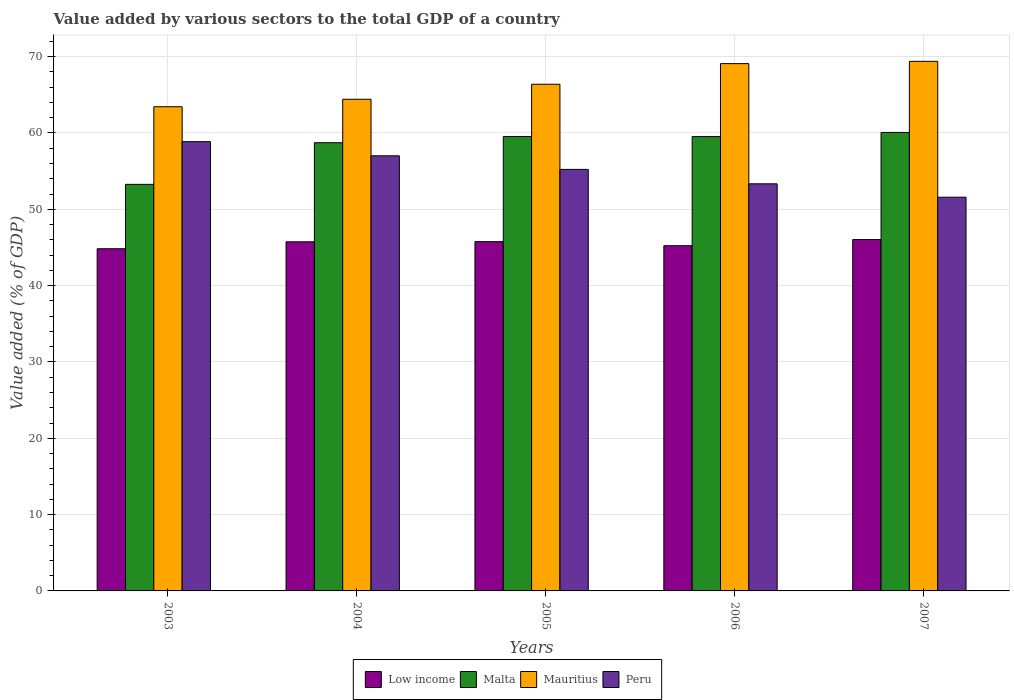How many different coloured bars are there?
Provide a short and direct response. 4. How many groups of bars are there?
Provide a succinct answer. 5. Are the number of bars on each tick of the X-axis equal?
Your response must be concise. Yes. How many bars are there on the 3rd tick from the right?
Keep it short and to the point. 4. What is the label of the 2nd group of bars from the left?
Your answer should be very brief. 2004. In how many cases, is the number of bars for a given year not equal to the number of legend labels?
Your answer should be compact. 0. What is the value added by various sectors to the total GDP in Peru in 2004?
Your answer should be very brief. 57.01. Across all years, what is the maximum value added by various sectors to the total GDP in Mauritius?
Offer a very short reply. 69.38. Across all years, what is the minimum value added by various sectors to the total GDP in Peru?
Keep it short and to the point. 51.58. In which year was the value added by various sectors to the total GDP in Mauritius maximum?
Make the answer very short. 2007. What is the total value added by various sectors to the total GDP in Peru in the graph?
Provide a short and direct response. 276.01. What is the difference between the value added by various sectors to the total GDP in Low income in 2005 and that in 2007?
Offer a terse response. -0.27. What is the difference between the value added by various sectors to the total GDP in Mauritius in 2006 and the value added by various sectors to the total GDP in Malta in 2004?
Give a very brief answer. 10.36. What is the average value added by various sectors to the total GDP in Peru per year?
Keep it short and to the point. 55.2. In the year 2007, what is the difference between the value added by various sectors to the total GDP in Low income and value added by various sectors to the total GDP in Peru?
Provide a short and direct response. -5.55. In how many years, is the value added by various sectors to the total GDP in Low income greater than 64 %?
Your answer should be compact. 0. What is the ratio of the value added by various sectors to the total GDP in Mauritius in 2006 to that in 2007?
Ensure brevity in your answer.  1. Is the difference between the value added by various sectors to the total GDP in Low income in 2005 and 2007 greater than the difference between the value added by various sectors to the total GDP in Peru in 2005 and 2007?
Offer a very short reply. No. What is the difference between the highest and the second highest value added by various sectors to the total GDP in Low income?
Provide a short and direct response. 0.27. What is the difference between the highest and the lowest value added by various sectors to the total GDP in Malta?
Ensure brevity in your answer.  6.8. In how many years, is the value added by various sectors to the total GDP in Low income greater than the average value added by various sectors to the total GDP in Low income taken over all years?
Make the answer very short. 3. Is it the case that in every year, the sum of the value added by various sectors to the total GDP in Peru and value added by various sectors to the total GDP in Mauritius is greater than the sum of value added by various sectors to the total GDP in Malta and value added by various sectors to the total GDP in Low income?
Give a very brief answer. Yes. What does the 4th bar from the left in 2004 represents?
Give a very brief answer. Peru. What does the 4th bar from the right in 2004 represents?
Ensure brevity in your answer.  Low income. What is the difference between two consecutive major ticks on the Y-axis?
Keep it short and to the point. 10. Are the values on the major ticks of Y-axis written in scientific E-notation?
Offer a terse response. No. Where does the legend appear in the graph?
Ensure brevity in your answer.  Bottom center. How many legend labels are there?
Provide a short and direct response. 4. What is the title of the graph?
Offer a very short reply. Value added by various sectors to the total GDP of a country. Does "East Asia (developing only)" appear as one of the legend labels in the graph?
Make the answer very short. No. What is the label or title of the Y-axis?
Ensure brevity in your answer.  Value added (% of GDP). What is the Value added (% of GDP) of Low income in 2003?
Provide a succinct answer. 44.83. What is the Value added (% of GDP) in Malta in 2003?
Give a very brief answer. 53.27. What is the Value added (% of GDP) of Mauritius in 2003?
Ensure brevity in your answer.  63.44. What is the Value added (% of GDP) of Peru in 2003?
Your answer should be very brief. 58.86. What is the Value added (% of GDP) of Low income in 2004?
Make the answer very short. 45.74. What is the Value added (% of GDP) of Malta in 2004?
Ensure brevity in your answer.  58.72. What is the Value added (% of GDP) of Mauritius in 2004?
Your response must be concise. 64.42. What is the Value added (% of GDP) in Peru in 2004?
Your response must be concise. 57.01. What is the Value added (% of GDP) in Low income in 2005?
Provide a succinct answer. 45.76. What is the Value added (% of GDP) of Malta in 2005?
Offer a very short reply. 59.53. What is the Value added (% of GDP) of Mauritius in 2005?
Your answer should be compact. 66.38. What is the Value added (% of GDP) in Peru in 2005?
Your response must be concise. 55.23. What is the Value added (% of GDP) of Low income in 2006?
Your answer should be very brief. 45.23. What is the Value added (% of GDP) of Malta in 2006?
Ensure brevity in your answer.  59.52. What is the Value added (% of GDP) in Mauritius in 2006?
Offer a terse response. 69.08. What is the Value added (% of GDP) in Peru in 2006?
Give a very brief answer. 53.34. What is the Value added (% of GDP) in Low income in 2007?
Provide a succinct answer. 46.03. What is the Value added (% of GDP) in Malta in 2007?
Keep it short and to the point. 60.07. What is the Value added (% of GDP) of Mauritius in 2007?
Your answer should be very brief. 69.38. What is the Value added (% of GDP) of Peru in 2007?
Your response must be concise. 51.58. Across all years, what is the maximum Value added (% of GDP) in Low income?
Ensure brevity in your answer.  46.03. Across all years, what is the maximum Value added (% of GDP) of Malta?
Your answer should be compact. 60.07. Across all years, what is the maximum Value added (% of GDP) of Mauritius?
Make the answer very short. 69.38. Across all years, what is the maximum Value added (% of GDP) of Peru?
Offer a terse response. 58.86. Across all years, what is the minimum Value added (% of GDP) in Low income?
Give a very brief answer. 44.83. Across all years, what is the minimum Value added (% of GDP) in Malta?
Offer a very short reply. 53.27. Across all years, what is the minimum Value added (% of GDP) of Mauritius?
Provide a short and direct response. 63.44. Across all years, what is the minimum Value added (% of GDP) of Peru?
Provide a short and direct response. 51.58. What is the total Value added (% of GDP) in Low income in the graph?
Make the answer very short. 227.59. What is the total Value added (% of GDP) of Malta in the graph?
Your answer should be very brief. 291.11. What is the total Value added (% of GDP) in Mauritius in the graph?
Ensure brevity in your answer.  332.7. What is the total Value added (% of GDP) in Peru in the graph?
Offer a terse response. 276.01. What is the difference between the Value added (% of GDP) of Low income in 2003 and that in 2004?
Ensure brevity in your answer.  -0.91. What is the difference between the Value added (% of GDP) of Malta in 2003 and that in 2004?
Offer a very short reply. -5.45. What is the difference between the Value added (% of GDP) of Mauritius in 2003 and that in 2004?
Give a very brief answer. -0.98. What is the difference between the Value added (% of GDP) in Peru in 2003 and that in 2004?
Provide a short and direct response. 1.85. What is the difference between the Value added (% of GDP) of Low income in 2003 and that in 2005?
Your response must be concise. -0.93. What is the difference between the Value added (% of GDP) in Malta in 2003 and that in 2005?
Offer a very short reply. -6.26. What is the difference between the Value added (% of GDP) of Mauritius in 2003 and that in 2005?
Provide a short and direct response. -2.95. What is the difference between the Value added (% of GDP) in Peru in 2003 and that in 2005?
Your response must be concise. 3.63. What is the difference between the Value added (% of GDP) in Low income in 2003 and that in 2006?
Keep it short and to the point. -0.4. What is the difference between the Value added (% of GDP) of Malta in 2003 and that in 2006?
Make the answer very short. -6.26. What is the difference between the Value added (% of GDP) of Mauritius in 2003 and that in 2006?
Your answer should be very brief. -5.65. What is the difference between the Value added (% of GDP) of Peru in 2003 and that in 2006?
Keep it short and to the point. 5.52. What is the difference between the Value added (% of GDP) in Low income in 2003 and that in 2007?
Your answer should be compact. -1.2. What is the difference between the Value added (% of GDP) in Malta in 2003 and that in 2007?
Your response must be concise. -6.8. What is the difference between the Value added (% of GDP) in Mauritius in 2003 and that in 2007?
Your answer should be compact. -5.95. What is the difference between the Value added (% of GDP) of Peru in 2003 and that in 2007?
Offer a very short reply. 7.28. What is the difference between the Value added (% of GDP) in Low income in 2004 and that in 2005?
Provide a short and direct response. -0.02. What is the difference between the Value added (% of GDP) of Malta in 2004 and that in 2005?
Provide a short and direct response. -0.81. What is the difference between the Value added (% of GDP) of Mauritius in 2004 and that in 2005?
Offer a very short reply. -1.97. What is the difference between the Value added (% of GDP) of Peru in 2004 and that in 2005?
Provide a succinct answer. 1.78. What is the difference between the Value added (% of GDP) of Low income in 2004 and that in 2006?
Make the answer very short. 0.51. What is the difference between the Value added (% of GDP) of Malta in 2004 and that in 2006?
Provide a short and direct response. -0.8. What is the difference between the Value added (% of GDP) of Mauritius in 2004 and that in 2006?
Make the answer very short. -4.67. What is the difference between the Value added (% of GDP) in Peru in 2004 and that in 2006?
Keep it short and to the point. 3.67. What is the difference between the Value added (% of GDP) in Low income in 2004 and that in 2007?
Give a very brief answer. -0.3. What is the difference between the Value added (% of GDP) in Malta in 2004 and that in 2007?
Keep it short and to the point. -1.35. What is the difference between the Value added (% of GDP) of Mauritius in 2004 and that in 2007?
Make the answer very short. -4.97. What is the difference between the Value added (% of GDP) in Peru in 2004 and that in 2007?
Ensure brevity in your answer.  5.43. What is the difference between the Value added (% of GDP) in Low income in 2005 and that in 2006?
Ensure brevity in your answer.  0.53. What is the difference between the Value added (% of GDP) of Malta in 2005 and that in 2006?
Ensure brevity in your answer.  0. What is the difference between the Value added (% of GDP) of Mauritius in 2005 and that in 2006?
Keep it short and to the point. -2.7. What is the difference between the Value added (% of GDP) in Peru in 2005 and that in 2006?
Ensure brevity in your answer.  1.89. What is the difference between the Value added (% of GDP) of Low income in 2005 and that in 2007?
Give a very brief answer. -0.27. What is the difference between the Value added (% of GDP) of Malta in 2005 and that in 2007?
Provide a short and direct response. -0.54. What is the difference between the Value added (% of GDP) in Mauritius in 2005 and that in 2007?
Make the answer very short. -3. What is the difference between the Value added (% of GDP) of Peru in 2005 and that in 2007?
Your answer should be very brief. 3.64. What is the difference between the Value added (% of GDP) in Low income in 2006 and that in 2007?
Your answer should be compact. -0.81. What is the difference between the Value added (% of GDP) of Malta in 2006 and that in 2007?
Provide a succinct answer. -0.54. What is the difference between the Value added (% of GDP) in Mauritius in 2006 and that in 2007?
Your response must be concise. -0.3. What is the difference between the Value added (% of GDP) in Peru in 2006 and that in 2007?
Make the answer very short. 1.76. What is the difference between the Value added (% of GDP) in Low income in 2003 and the Value added (% of GDP) in Malta in 2004?
Provide a succinct answer. -13.89. What is the difference between the Value added (% of GDP) in Low income in 2003 and the Value added (% of GDP) in Mauritius in 2004?
Give a very brief answer. -19.59. What is the difference between the Value added (% of GDP) in Low income in 2003 and the Value added (% of GDP) in Peru in 2004?
Offer a terse response. -12.18. What is the difference between the Value added (% of GDP) in Malta in 2003 and the Value added (% of GDP) in Mauritius in 2004?
Make the answer very short. -11.15. What is the difference between the Value added (% of GDP) of Malta in 2003 and the Value added (% of GDP) of Peru in 2004?
Provide a short and direct response. -3.74. What is the difference between the Value added (% of GDP) in Mauritius in 2003 and the Value added (% of GDP) in Peru in 2004?
Provide a short and direct response. 6.43. What is the difference between the Value added (% of GDP) in Low income in 2003 and the Value added (% of GDP) in Malta in 2005?
Give a very brief answer. -14.7. What is the difference between the Value added (% of GDP) of Low income in 2003 and the Value added (% of GDP) of Mauritius in 2005?
Provide a succinct answer. -21.55. What is the difference between the Value added (% of GDP) of Low income in 2003 and the Value added (% of GDP) of Peru in 2005?
Provide a succinct answer. -10.4. What is the difference between the Value added (% of GDP) in Malta in 2003 and the Value added (% of GDP) in Mauritius in 2005?
Your answer should be very brief. -13.12. What is the difference between the Value added (% of GDP) of Malta in 2003 and the Value added (% of GDP) of Peru in 2005?
Provide a succinct answer. -1.96. What is the difference between the Value added (% of GDP) in Mauritius in 2003 and the Value added (% of GDP) in Peru in 2005?
Keep it short and to the point. 8.21. What is the difference between the Value added (% of GDP) of Low income in 2003 and the Value added (% of GDP) of Malta in 2006?
Provide a succinct answer. -14.69. What is the difference between the Value added (% of GDP) of Low income in 2003 and the Value added (% of GDP) of Mauritius in 2006?
Ensure brevity in your answer.  -24.25. What is the difference between the Value added (% of GDP) in Low income in 2003 and the Value added (% of GDP) in Peru in 2006?
Give a very brief answer. -8.51. What is the difference between the Value added (% of GDP) in Malta in 2003 and the Value added (% of GDP) in Mauritius in 2006?
Keep it short and to the point. -15.82. What is the difference between the Value added (% of GDP) in Malta in 2003 and the Value added (% of GDP) in Peru in 2006?
Your answer should be compact. -0.07. What is the difference between the Value added (% of GDP) in Mauritius in 2003 and the Value added (% of GDP) in Peru in 2006?
Provide a short and direct response. 10.1. What is the difference between the Value added (% of GDP) in Low income in 2003 and the Value added (% of GDP) in Malta in 2007?
Keep it short and to the point. -15.24. What is the difference between the Value added (% of GDP) in Low income in 2003 and the Value added (% of GDP) in Mauritius in 2007?
Provide a succinct answer. -24.55. What is the difference between the Value added (% of GDP) of Low income in 2003 and the Value added (% of GDP) of Peru in 2007?
Provide a short and direct response. -6.75. What is the difference between the Value added (% of GDP) of Malta in 2003 and the Value added (% of GDP) of Mauritius in 2007?
Ensure brevity in your answer.  -16.11. What is the difference between the Value added (% of GDP) of Malta in 2003 and the Value added (% of GDP) of Peru in 2007?
Give a very brief answer. 1.69. What is the difference between the Value added (% of GDP) of Mauritius in 2003 and the Value added (% of GDP) of Peru in 2007?
Your response must be concise. 11.85. What is the difference between the Value added (% of GDP) of Low income in 2004 and the Value added (% of GDP) of Malta in 2005?
Keep it short and to the point. -13.79. What is the difference between the Value added (% of GDP) in Low income in 2004 and the Value added (% of GDP) in Mauritius in 2005?
Offer a very short reply. -20.64. What is the difference between the Value added (% of GDP) of Low income in 2004 and the Value added (% of GDP) of Peru in 2005?
Offer a terse response. -9.49. What is the difference between the Value added (% of GDP) in Malta in 2004 and the Value added (% of GDP) in Mauritius in 2005?
Offer a terse response. -7.66. What is the difference between the Value added (% of GDP) of Malta in 2004 and the Value added (% of GDP) of Peru in 2005?
Offer a very short reply. 3.5. What is the difference between the Value added (% of GDP) of Mauritius in 2004 and the Value added (% of GDP) of Peru in 2005?
Keep it short and to the point. 9.19. What is the difference between the Value added (% of GDP) in Low income in 2004 and the Value added (% of GDP) in Malta in 2006?
Offer a terse response. -13.79. What is the difference between the Value added (% of GDP) of Low income in 2004 and the Value added (% of GDP) of Mauritius in 2006?
Your answer should be compact. -23.35. What is the difference between the Value added (% of GDP) of Low income in 2004 and the Value added (% of GDP) of Peru in 2006?
Your answer should be compact. -7.6. What is the difference between the Value added (% of GDP) in Malta in 2004 and the Value added (% of GDP) in Mauritius in 2006?
Give a very brief answer. -10.36. What is the difference between the Value added (% of GDP) of Malta in 2004 and the Value added (% of GDP) of Peru in 2006?
Make the answer very short. 5.39. What is the difference between the Value added (% of GDP) in Mauritius in 2004 and the Value added (% of GDP) in Peru in 2006?
Give a very brief answer. 11.08. What is the difference between the Value added (% of GDP) of Low income in 2004 and the Value added (% of GDP) of Malta in 2007?
Offer a very short reply. -14.33. What is the difference between the Value added (% of GDP) of Low income in 2004 and the Value added (% of GDP) of Mauritius in 2007?
Provide a short and direct response. -23.64. What is the difference between the Value added (% of GDP) of Low income in 2004 and the Value added (% of GDP) of Peru in 2007?
Your response must be concise. -5.84. What is the difference between the Value added (% of GDP) in Malta in 2004 and the Value added (% of GDP) in Mauritius in 2007?
Provide a succinct answer. -10.66. What is the difference between the Value added (% of GDP) of Malta in 2004 and the Value added (% of GDP) of Peru in 2007?
Your answer should be compact. 7.14. What is the difference between the Value added (% of GDP) in Mauritius in 2004 and the Value added (% of GDP) in Peru in 2007?
Make the answer very short. 12.83. What is the difference between the Value added (% of GDP) of Low income in 2005 and the Value added (% of GDP) of Malta in 2006?
Give a very brief answer. -13.76. What is the difference between the Value added (% of GDP) of Low income in 2005 and the Value added (% of GDP) of Mauritius in 2006?
Your response must be concise. -23.32. What is the difference between the Value added (% of GDP) in Low income in 2005 and the Value added (% of GDP) in Peru in 2006?
Your response must be concise. -7.58. What is the difference between the Value added (% of GDP) of Malta in 2005 and the Value added (% of GDP) of Mauritius in 2006?
Offer a very short reply. -9.56. What is the difference between the Value added (% of GDP) in Malta in 2005 and the Value added (% of GDP) in Peru in 2006?
Offer a very short reply. 6.19. What is the difference between the Value added (% of GDP) of Mauritius in 2005 and the Value added (% of GDP) of Peru in 2006?
Provide a short and direct response. 13.05. What is the difference between the Value added (% of GDP) of Low income in 2005 and the Value added (% of GDP) of Malta in 2007?
Make the answer very short. -14.31. What is the difference between the Value added (% of GDP) in Low income in 2005 and the Value added (% of GDP) in Mauritius in 2007?
Offer a terse response. -23.62. What is the difference between the Value added (% of GDP) in Low income in 2005 and the Value added (% of GDP) in Peru in 2007?
Make the answer very short. -5.82. What is the difference between the Value added (% of GDP) of Malta in 2005 and the Value added (% of GDP) of Mauritius in 2007?
Provide a short and direct response. -9.85. What is the difference between the Value added (% of GDP) in Malta in 2005 and the Value added (% of GDP) in Peru in 2007?
Keep it short and to the point. 7.95. What is the difference between the Value added (% of GDP) of Mauritius in 2005 and the Value added (% of GDP) of Peru in 2007?
Give a very brief answer. 14.8. What is the difference between the Value added (% of GDP) of Low income in 2006 and the Value added (% of GDP) of Malta in 2007?
Ensure brevity in your answer.  -14.84. What is the difference between the Value added (% of GDP) in Low income in 2006 and the Value added (% of GDP) in Mauritius in 2007?
Make the answer very short. -24.15. What is the difference between the Value added (% of GDP) in Low income in 2006 and the Value added (% of GDP) in Peru in 2007?
Provide a succinct answer. -6.35. What is the difference between the Value added (% of GDP) of Malta in 2006 and the Value added (% of GDP) of Mauritius in 2007?
Provide a short and direct response. -9.86. What is the difference between the Value added (% of GDP) in Malta in 2006 and the Value added (% of GDP) in Peru in 2007?
Make the answer very short. 7.94. What is the difference between the Value added (% of GDP) in Mauritius in 2006 and the Value added (% of GDP) in Peru in 2007?
Make the answer very short. 17.5. What is the average Value added (% of GDP) of Low income per year?
Offer a very short reply. 45.52. What is the average Value added (% of GDP) of Malta per year?
Give a very brief answer. 58.22. What is the average Value added (% of GDP) in Mauritius per year?
Provide a succinct answer. 66.54. What is the average Value added (% of GDP) of Peru per year?
Give a very brief answer. 55.2. In the year 2003, what is the difference between the Value added (% of GDP) in Low income and Value added (% of GDP) in Malta?
Make the answer very short. -8.44. In the year 2003, what is the difference between the Value added (% of GDP) in Low income and Value added (% of GDP) in Mauritius?
Make the answer very short. -18.61. In the year 2003, what is the difference between the Value added (% of GDP) in Low income and Value added (% of GDP) in Peru?
Offer a very short reply. -14.03. In the year 2003, what is the difference between the Value added (% of GDP) in Malta and Value added (% of GDP) in Mauritius?
Make the answer very short. -10.17. In the year 2003, what is the difference between the Value added (% of GDP) in Malta and Value added (% of GDP) in Peru?
Your answer should be compact. -5.59. In the year 2003, what is the difference between the Value added (% of GDP) of Mauritius and Value added (% of GDP) of Peru?
Your answer should be very brief. 4.58. In the year 2004, what is the difference between the Value added (% of GDP) of Low income and Value added (% of GDP) of Malta?
Ensure brevity in your answer.  -12.98. In the year 2004, what is the difference between the Value added (% of GDP) of Low income and Value added (% of GDP) of Mauritius?
Make the answer very short. -18.68. In the year 2004, what is the difference between the Value added (% of GDP) in Low income and Value added (% of GDP) in Peru?
Offer a terse response. -11.27. In the year 2004, what is the difference between the Value added (% of GDP) in Malta and Value added (% of GDP) in Mauritius?
Offer a terse response. -5.69. In the year 2004, what is the difference between the Value added (% of GDP) of Malta and Value added (% of GDP) of Peru?
Provide a short and direct response. 1.71. In the year 2004, what is the difference between the Value added (% of GDP) of Mauritius and Value added (% of GDP) of Peru?
Your answer should be compact. 7.41. In the year 2005, what is the difference between the Value added (% of GDP) of Low income and Value added (% of GDP) of Malta?
Provide a short and direct response. -13.77. In the year 2005, what is the difference between the Value added (% of GDP) in Low income and Value added (% of GDP) in Mauritius?
Provide a short and direct response. -20.62. In the year 2005, what is the difference between the Value added (% of GDP) in Low income and Value added (% of GDP) in Peru?
Ensure brevity in your answer.  -9.47. In the year 2005, what is the difference between the Value added (% of GDP) in Malta and Value added (% of GDP) in Mauritius?
Offer a terse response. -6.85. In the year 2005, what is the difference between the Value added (% of GDP) of Malta and Value added (% of GDP) of Peru?
Keep it short and to the point. 4.3. In the year 2005, what is the difference between the Value added (% of GDP) in Mauritius and Value added (% of GDP) in Peru?
Make the answer very short. 11.16. In the year 2006, what is the difference between the Value added (% of GDP) of Low income and Value added (% of GDP) of Malta?
Give a very brief answer. -14.3. In the year 2006, what is the difference between the Value added (% of GDP) of Low income and Value added (% of GDP) of Mauritius?
Give a very brief answer. -23.86. In the year 2006, what is the difference between the Value added (% of GDP) in Low income and Value added (% of GDP) in Peru?
Your answer should be compact. -8.11. In the year 2006, what is the difference between the Value added (% of GDP) in Malta and Value added (% of GDP) in Mauritius?
Your response must be concise. -9.56. In the year 2006, what is the difference between the Value added (% of GDP) of Malta and Value added (% of GDP) of Peru?
Your response must be concise. 6.19. In the year 2006, what is the difference between the Value added (% of GDP) of Mauritius and Value added (% of GDP) of Peru?
Ensure brevity in your answer.  15.75. In the year 2007, what is the difference between the Value added (% of GDP) of Low income and Value added (% of GDP) of Malta?
Your response must be concise. -14.03. In the year 2007, what is the difference between the Value added (% of GDP) in Low income and Value added (% of GDP) in Mauritius?
Your answer should be compact. -23.35. In the year 2007, what is the difference between the Value added (% of GDP) of Low income and Value added (% of GDP) of Peru?
Give a very brief answer. -5.55. In the year 2007, what is the difference between the Value added (% of GDP) in Malta and Value added (% of GDP) in Mauritius?
Make the answer very short. -9.31. In the year 2007, what is the difference between the Value added (% of GDP) of Malta and Value added (% of GDP) of Peru?
Your response must be concise. 8.49. In the year 2007, what is the difference between the Value added (% of GDP) of Mauritius and Value added (% of GDP) of Peru?
Ensure brevity in your answer.  17.8. What is the ratio of the Value added (% of GDP) in Low income in 2003 to that in 2004?
Offer a very short reply. 0.98. What is the ratio of the Value added (% of GDP) in Malta in 2003 to that in 2004?
Give a very brief answer. 0.91. What is the ratio of the Value added (% of GDP) of Mauritius in 2003 to that in 2004?
Ensure brevity in your answer.  0.98. What is the ratio of the Value added (% of GDP) of Peru in 2003 to that in 2004?
Provide a succinct answer. 1.03. What is the ratio of the Value added (% of GDP) of Low income in 2003 to that in 2005?
Your answer should be compact. 0.98. What is the ratio of the Value added (% of GDP) of Malta in 2003 to that in 2005?
Ensure brevity in your answer.  0.89. What is the ratio of the Value added (% of GDP) in Mauritius in 2003 to that in 2005?
Give a very brief answer. 0.96. What is the ratio of the Value added (% of GDP) of Peru in 2003 to that in 2005?
Ensure brevity in your answer.  1.07. What is the ratio of the Value added (% of GDP) of Low income in 2003 to that in 2006?
Keep it short and to the point. 0.99. What is the ratio of the Value added (% of GDP) of Malta in 2003 to that in 2006?
Offer a very short reply. 0.89. What is the ratio of the Value added (% of GDP) in Mauritius in 2003 to that in 2006?
Keep it short and to the point. 0.92. What is the ratio of the Value added (% of GDP) of Peru in 2003 to that in 2006?
Offer a very short reply. 1.1. What is the ratio of the Value added (% of GDP) in Low income in 2003 to that in 2007?
Ensure brevity in your answer.  0.97. What is the ratio of the Value added (% of GDP) in Malta in 2003 to that in 2007?
Offer a terse response. 0.89. What is the ratio of the Value added (% of GDP) of Mauritius in 2003 to that in 2007?
Give a very brief answer. 0.91. What is the ratio of the Value added (% of GDP) in Peru in 2003 to that in 2007?
Offer a very short reply. 1.14. What is the ratio of the Value added (% of GDP) in Low income in 2004 to that in 2005?
Provide a short and direct response. 1. What is the ratio of the Value added (% of GDP) of Malta in 2004 to that in 2005?
Offer a very short reply. 0.99. What is the ratio of the Value added (% of GDP) of Mauritius in 2004 to that in 2005?
Offer a terse response. 0.97. What is the ratio of the Value added (% of GDP) of Peru in 2004 to that in 2005?
Offer a terse response. 1.03. What is the ratio of the Value added (% of GDP) of Low income in 2004 to that in 2006?
Keep it short and to the point. 1.01. What is the ratio of the Value added (% of GDP) of Malta in 2004 to that in 2006?
Ensure brevity in your answer.  0.99. What is the ratio of the Value added (% of GDP) in Mauritius in 2004 to that in 2006?
Your answer should be compact. 0.93. What is the ratio of the Value added (% of GDP) in Peru in 2004 to that in 2006?
Your answer should be compact. 1.07. What is the ratio of the Value added (% of GDP) of Low income in 2004 to that in 2007?
Make the answer very short. 0.99. What is the ratio of the Value added (% of GDP) in Malta in 2004 to that in 2007?
Offer a terse response. 0.98. What is the ratio of the Value added (% of GDP) in Mauritius in 2004 to that in 2007?
Provide a short and direct response. 0.93. What is the ratio of the Value added (% of GDP) in Peru in 2004 to that in 2007?
Provide a succinct answer. 1.11. What is the ratio of the Value added (% of GDP) of Low income in 2005 to that in 2006?
Make the answer very short. 1.01. What is the ratio of the Value added (% of GDP) of Malta in 2005 to that in 2006?
Offer a terse response. 1. What is the ratio of the Value added (% of GDP) of Mauritius in 2005 to that in 2006?
Your response must be concise. 0.96. What is the ratio of the Value added (% of GDP) of Peru in 2005 to that in 2006?
Your answer should be compact. 1.04. What is the ratio of the Value added (% of GDP) in Mauritius in 2005 to that in 2007?
Make the answer very short. 0.96. What is the ratio of the Value added (% of GDP) of Peru in 2005 to that in 2007?
Your response must be concise. 1.07. What is the ratio of the Value added (% of GDP) in Low income in 2006 to that in 2007?
Your answer should be very brief. 0.98. What is the ratio of the Value added (% of GDP) in Malta in 2006 to that in 2007?
Provide a short and direct response. 0.99. What is the ratio of the Value added (% of GDP) of Mauritius in 2006 to that in 2007?
Give a very brief answer. 1. What is the ratio of the Value added (% of GDP) of Peru in 2006 to that in 2007?
Ensure brevity in your answer.  1.03. What is the difference between the highest and the second highest Value added (% of GDP) in Low income?
Your answer should be very brief. 0.27. What is the difference between the highest and the second highest Value added (% of GDP) of Malta?
Offer a terse response. 0.54. What is the difference between the highest and the second highest Value added (% of GDP) in Mauritius?
Your answer should be compact. 0.3. What is the difference between the highest and the second highest Value added (% of GDP) in Peru?
Make the answer very short. 1.85. What is the difference between the highest and the lowest Value added (% of GDP) of Low income?
Your answer should be very brief. 1.2. What is the difference between the highest and the lowest Value added (% of GDP) of Malta?
Ensure brevity in your answer.  6.8. What is the difference between the highest and the lowest Value added (% of GDP) of Mauritius?
Provide a succinct answer. 5.95. What is the difference between the highest and the lowest Value added (% of GDP) of Peru?
Give a very brief answer. 7.28. 